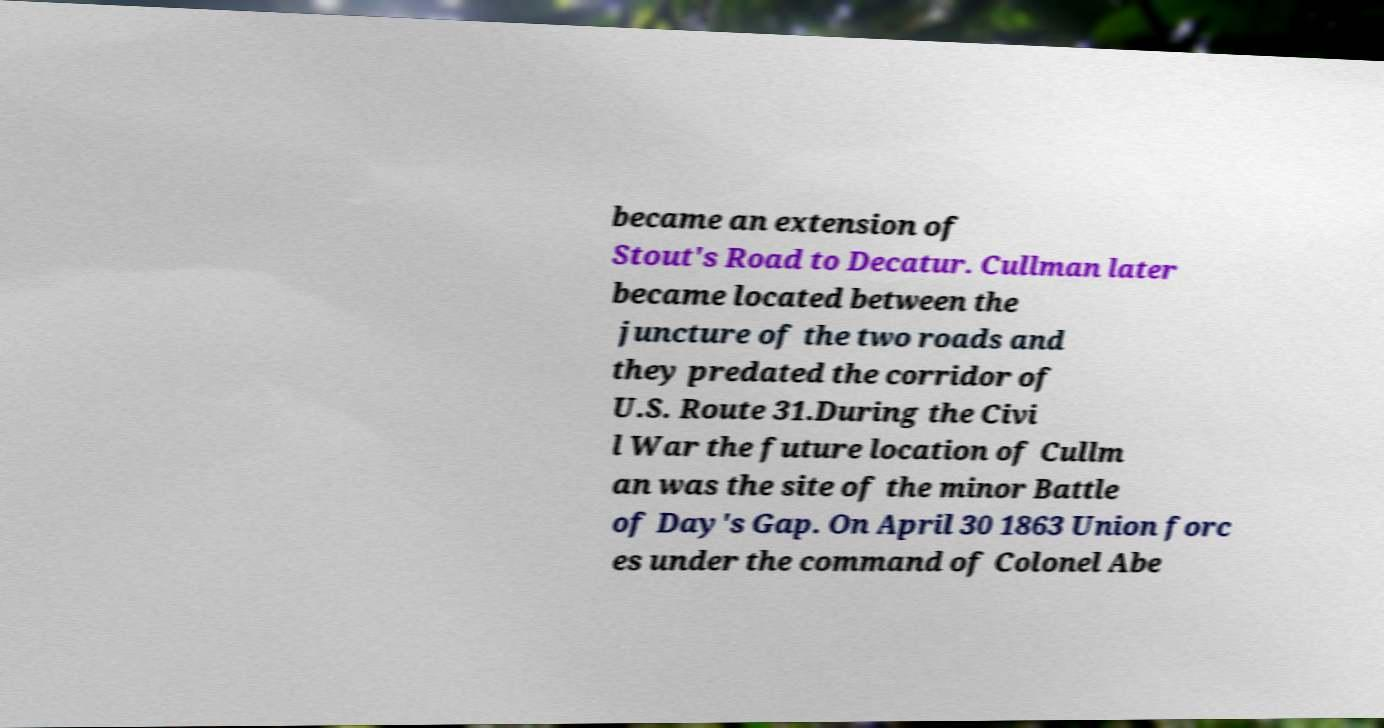What messages or text are displayed in this image? I need them in a readable, typed format. became an extension of Stout's Road to Decatur. Cullman later became located between the juncture of the two roads and they predated the corridor of U.S. Route 31.During the Civi l War the future location of Cullm an was the site of the minor Battle of Day's Gap. On April 30 1863 Union forc es under the command of Colonel Abe 